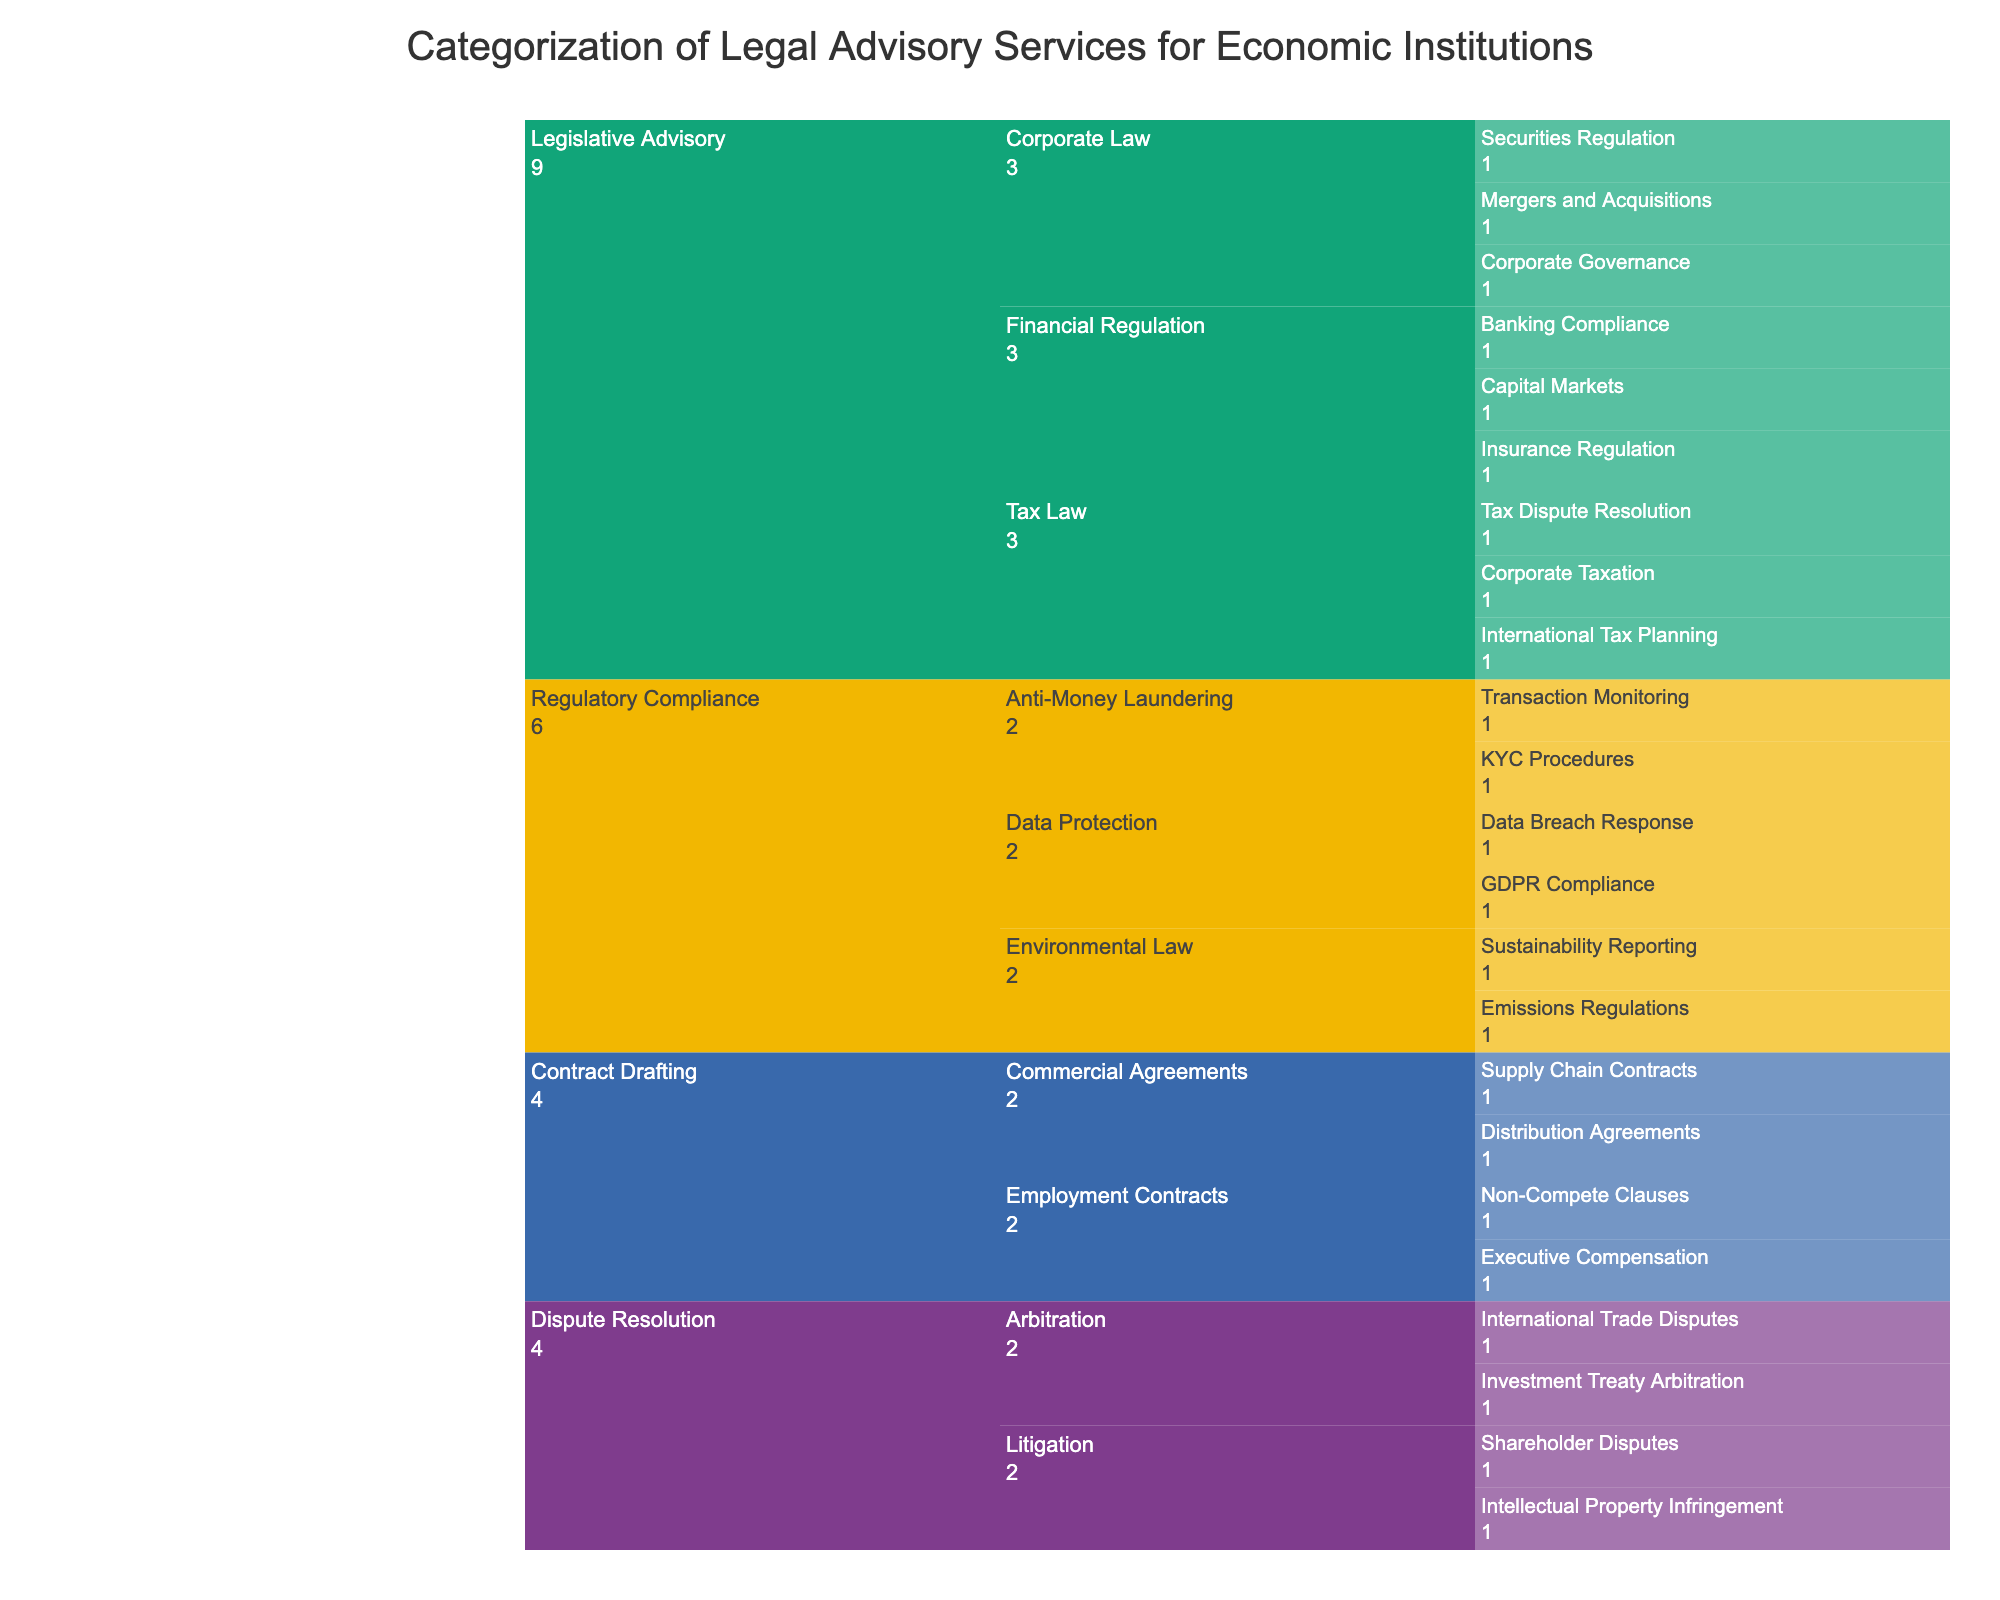What is the title of the chart? The title can be found at the top of the chart. It summarizes the main subject of the visualization. In this case, the title specifies the type of services and target audience.
Answer: Categorization of Legal Advisory Services for Economic Institutions How many subcategories are there under the 'Legislative Advisory' category? Count the number of unique subcategories listed under 'Legislative Advisory'. The Icicle chart organizes them hierarchically.
Answer: 3 Which subcategory under 'Regulatory Compliance' contains more services: 'Anti-Money Laundering' or 'Data Protection'? Compare the number of services listed under each subcategory by counting them from the chart. 'Anti-Money Laundering' has KYC Procedures and Transaction Monitoring while 'Data Protection' has GDPR Compliance and Data Breach Response.
Answer: Both contain 2 services each How many total services are listed in the 'Contract Drafting' category? Add up the services listed under each subcategory within 'Contract Drafting'. This includes two subcategories, each containing specific services.
Answer: 4 Which category has the largest number of subcategories? Count the number of subcategories directly under each main category. Compare these numbers to determine the category with the most subcategories.
Answer: Legislative Advisory What are the services provided under 'Dispute Resolution' and how are they categorized? Look at the hierarchy under 'Dispute Resolution'. Identify the subcategories and the services listed under each subcategory.
Answer: Shareholder Disputes and Intellectual Property Infringement under Litigation; International Trade Disputes and Investment Treaty Arbitration under Arbitration Identify the category and subcategory for the service 'Corporate Governance'. Trace the hierarchical path in the Icicle chart leading to 'Corporate Governance'. Start from the main category and follow through the subcategory.
Answer: Legislative Advisory, Corporate Law Which category, 'Legislative Advisory' or 'Regulatory Compliance', provides more distinct services? Count all the services under each category by traversing through their subcategories. Compare the total counts.
Answer: Legislative Advisory Which subcategory under 'Contract Drafting' deals with employment-related contracts? Look at the subcategories under 'Contract Drafting' and identify the keyword related to employment.
Answer: Employment Contracts If you combine 'Banking Compliance' and 'Capital Markets', how many services are included in the 'Financial Regulation' subcategory? Find services under 'Banking Compliance' and 'Capital Markets' within 'Financial Regulation'. Sum these values.
Answer: 2 